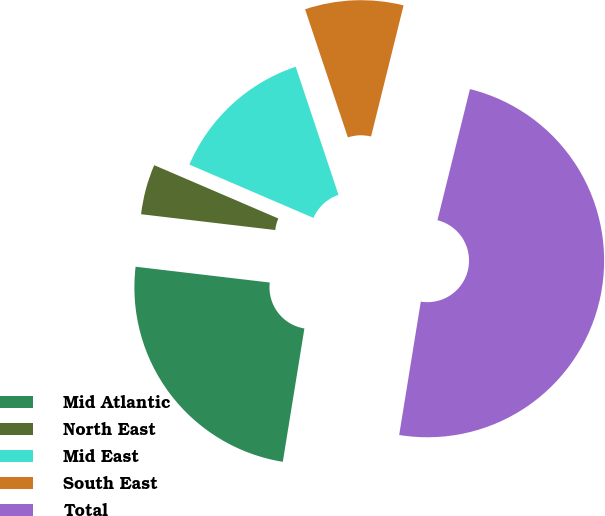Convert chart to OTSL. <chart><loc_0><loc_0><loc_500><loc_500><pie_chart><fcel>Mid Atlantic<fcel>North East<fcel>Mid East<fcel>South East<fcel>Total<nl><fcel>24.31%<fcel>4.59%<fcel>13.41%<fcel>9.0%<fcel>48.69%<nl></chart> 